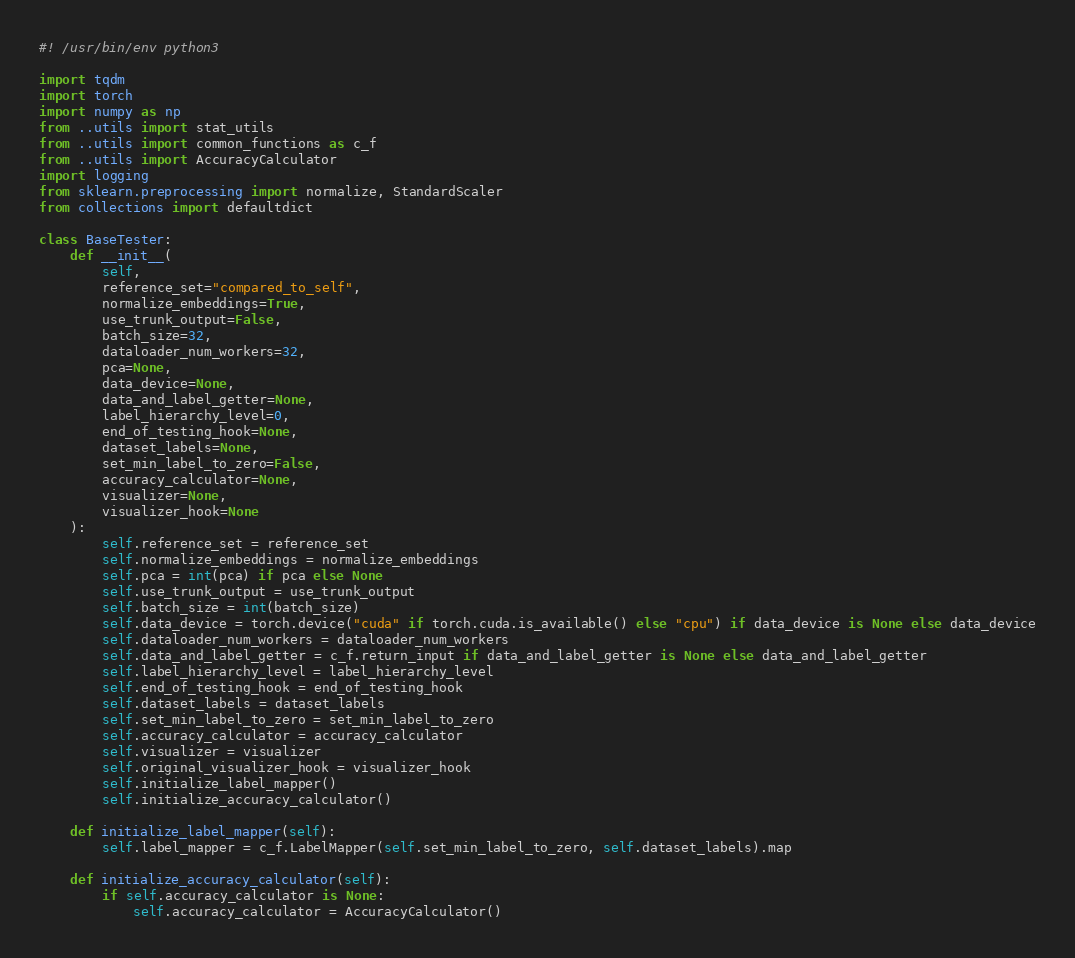<code> <loc_0><loc_0><loc_500><loc_500><_Python_>#! /usr/bin/env python3

import tqdm
import torch
import numpy as np
from ..utils import stat_utils
from ..utils import common_functions as c_f
from ..utils import AccuracyCalculator
import logging
from sklearn.preprocessing import normalize, StandardScaler
from collections import defaultdict

class BaseTester:
    def __init__(
        self, 
        reference_set="compared_to_self", 
        normalize_embeddings=True, 
        use_trunk_output=False, 
        batch_size=32, 
        dataloader_num_workers=32, 
        pca=None, 
        data_device=None,  
        data_and_label_getter=None, 
        label_hierarchy_level=0, 
        end_of_testing_hook=None,
        dataset_labels=None,
        set_min_label_to_zero=False,
        accuracy_calculator=None,
        visualizer=None,
        visualizer_hook=None
    ):
        self.reference_set = reference_set
        self.normalize_embeddings = normalize_embeddings
        self.pca = int(pca) if pca else None
        self.use_trunk_output = use_trunk_output
        self.batch_size = int(batch_size)
        self.data_device = torch.device("cuda" if torch.cuda.is_available() else "cpu") if data_device is None else data_device
        self.dataloader_num_workers = dataloader_num_workers
        self.data_and_label_getter = c_f.return_input if data_and_label_getter is None else data_and_label_getter
        self.label_hierarchy_level = label_hierarchy_level
        self.end_of_testing_hook = end_of_testing_hook
        self.dataset_labels = dataset_labels
        self.set_min_label_to_zero = set_min_label_to_zero
        self.accuracy_calculator = accuracy_calculator
        self.visualizer = visualizer
        self.original_visualizer_hook = visualizer_hook
        self.initialize_label_mapper()
        self.initialize_accuracy_calculator()         

    def initialize_label_mapper(self):
        self.label_mapper = c_f.LabelMapper(self.set_min_label_to_zero, self.dataset_labels).map

    def initialize_accuracy_calculator(self):
        if self.accuracy_calculator is None:
            self.accuracy_calculator = AccuracyCalculator()
</code> 